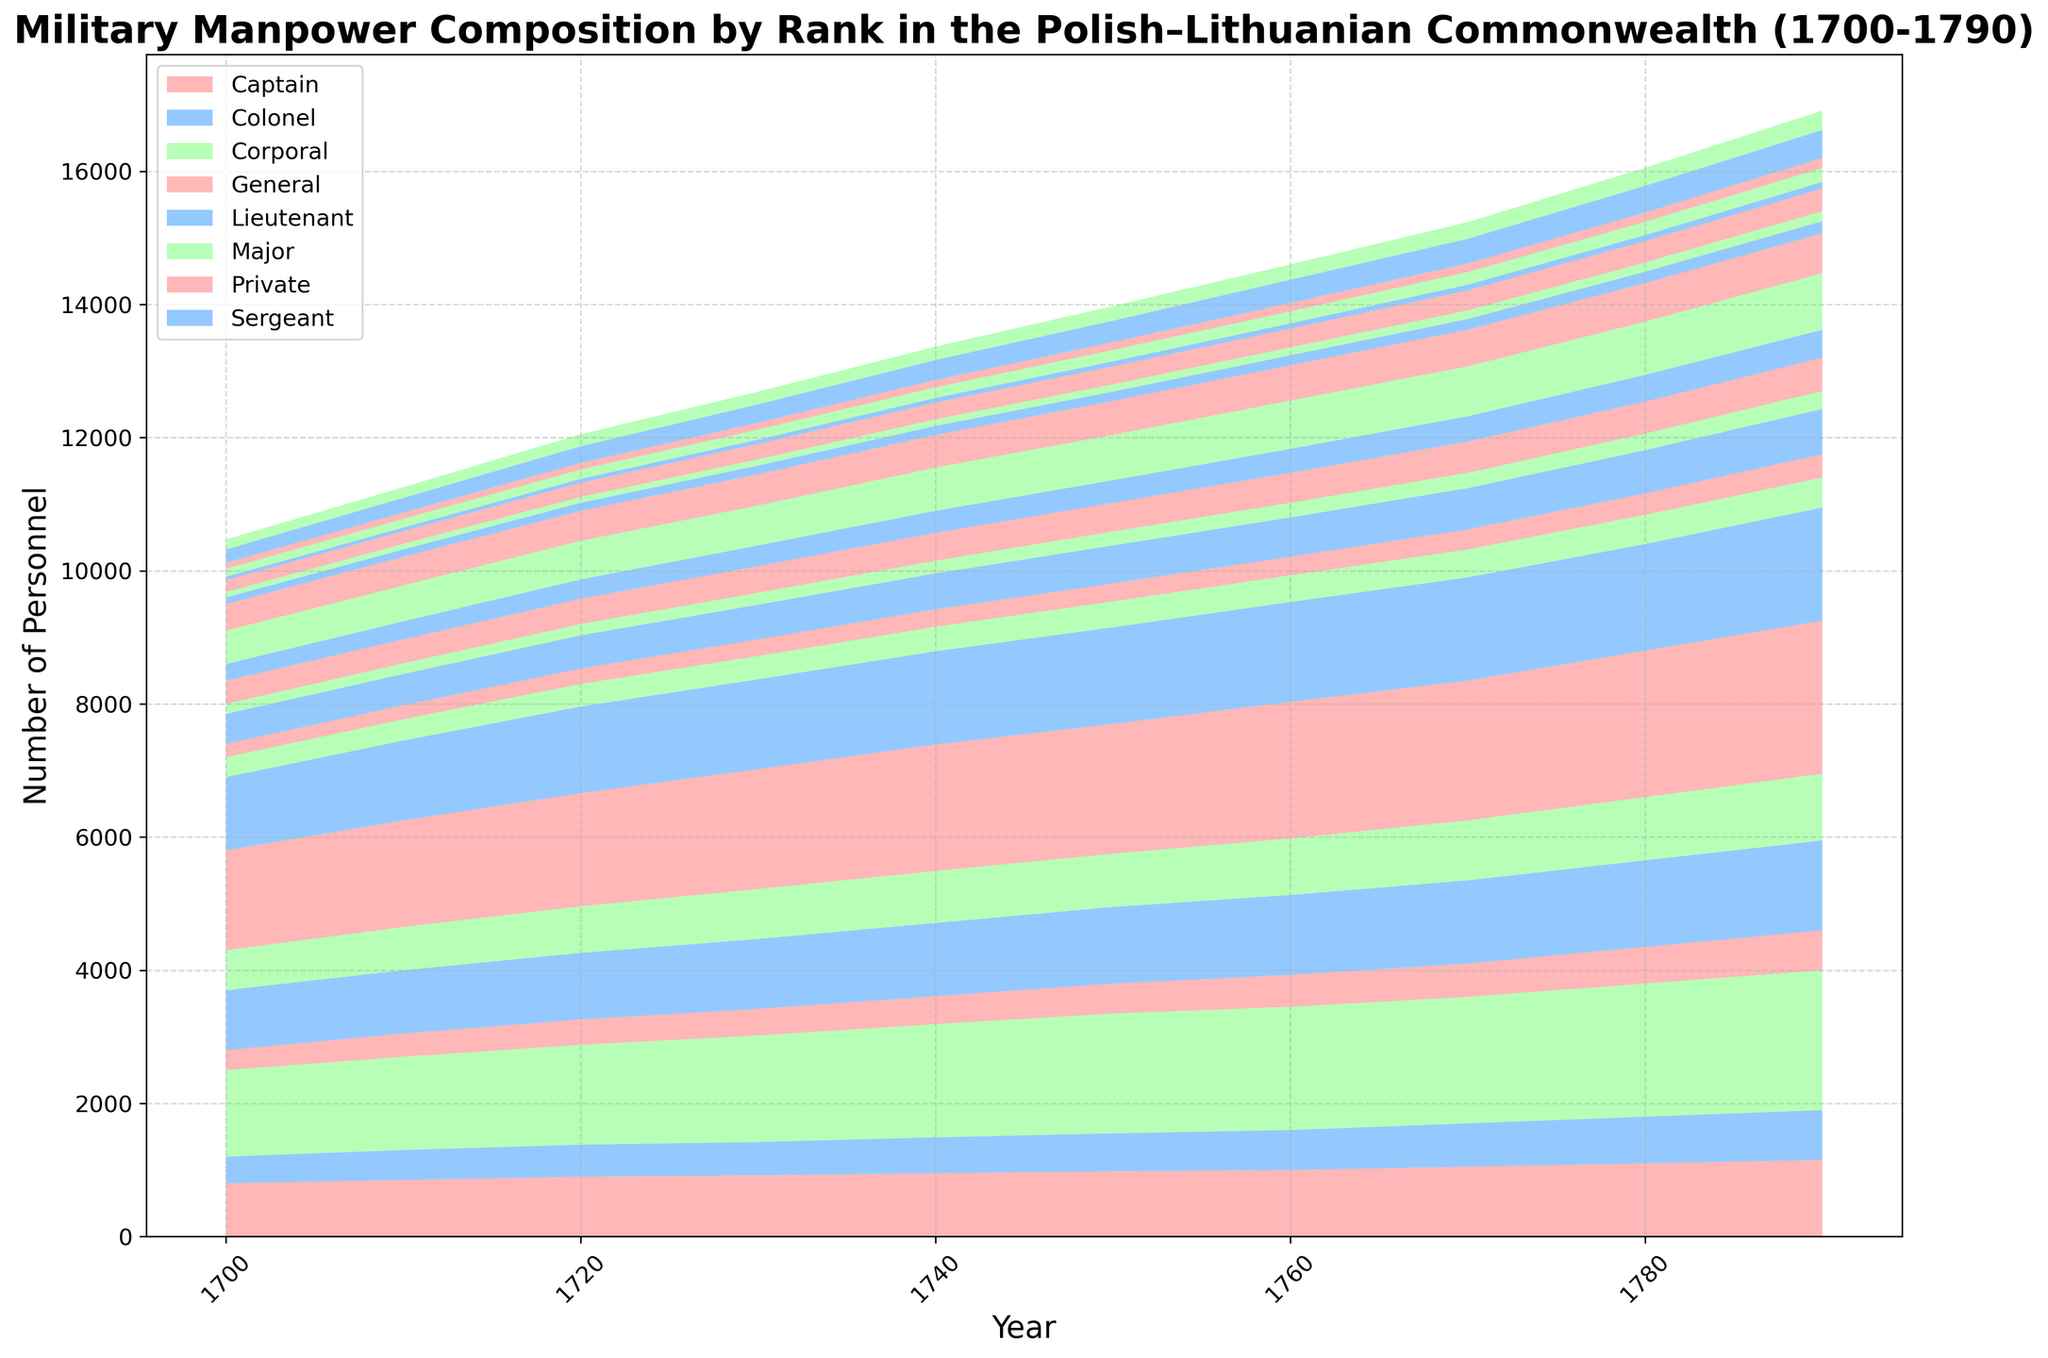what is the total number of personnel in the year 1750? To find the total number of personnel in 1750, add the numbers of officers, NCOs, and soldiers across all ranks. The plot shows stacked layers representing these categories. Sum them up visually.
Answer: Approximately 19,720 which year shows a significant increase in the number of soldiers across all ranks compared to the previous decade? Look for a year where the layer representing soldiers increases noticeably compared to the preceding year.
Answer: 1780 in terms of sheer numbers, which rank exhibits the most growth from 1700 to 1790 in the number of NCOs? Look at the difference in height of the blue layer (representing NCOs) for each rank between 1700 and 1790. Compare which rank has the largest increase.
Answer: Private how does the number of officers in 1790 compare to the number in 1700 for the rank of Captain? Compare the height of the red layer (officers) for Captain in 1790 versus 1700.
Answer: The number of officers increased by 80 (180 in 1790 compared to 100 in 1700) which rank has the highest total number of personnel in 1700? Compare the height of the stacked layers in 1700 for each rank and identify the tallest stack.
Answer: Private how does the total number of personnel change from 1750 to 1790 across all ranks? Observe the overall height of the stacked layers from 1750 compared to 1790 and note whether it increased, decreased, or stayed the same.
Answer: Increased which category (officers, NCOs, soldiers) contributed the most to the increase in total personnel from 1750 to 1790? Compare the increase in the height of each layer (color) from 1750 to 1790 across all ranks.
Answer: Soldiers what's the average number of soldiers across all ranks in 1750? Sum the number of soldiers for all ranks in 1750 and divide by the number of ranks (7).
Answer: Approximately 1,305 soldiers is there any rank where the number of officers decreased over time? Identify if any red layer segment for a rank is smaller in 1790 compared to any earlier year.
Answer: No which rank has the most consistent number of officers throughout the years? Evaluate the red layer's uniformity across years for each rank, the smallest fluctuation indicating consistency.
Answer: Corporal 